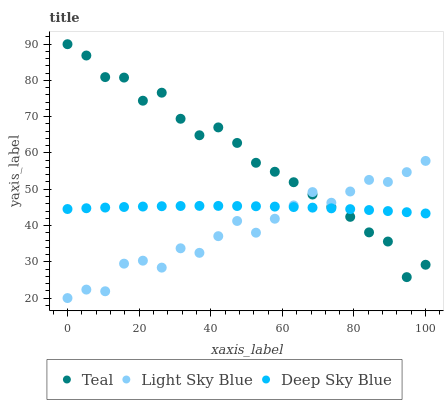Does Light Sky Blue have the minimum area under the curve?
Answer yes or no. Yes. Does Teal have the maximum area under the curve?
Answer yes or no. Yes. Does Deep Sky Blue have the minimum area under the curve?
Answer yes or no. No. Does Deep Sky Blue have the maximum area under the curve?
Answer yes or no. No. Is Deep Sky Blue the smoothest?
Answer yes or no. Yes. Is Teal the roughest?
Answer yes or no. Yes. Is Teal the smoothest?
Answer yes or no. No. Is Deep Sky Blue the roughest?
Answer yes or no. No. Does Light Sky Blue have the lowest value?
Answer yes or no. Yes. Does Teal have the lowest value?
Answer yes or no. No. Does Teal have the highest value?
Answer yes or no. Yes. Does Deep Sky Blue have the highest value?
Answer yes or no. No. Does Teal intersect Deep Sky Blue?
Answer yes or no. Yes. Is Teal less than Deep Sky Blue?
Answer yes or no. No. Is Teal greater than Deep Sky Blue?
Answer yes or no. No. 